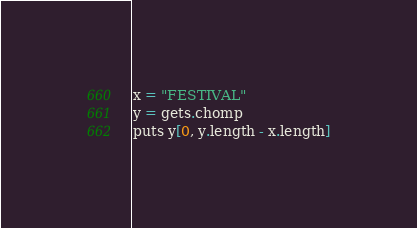<code> <loc_0><loc_0><loc_500><loc_500><_Ruby_>x = "FESTIVAL"
y = gets.chomp
puts y[0, y.length - x.length]
</code> 